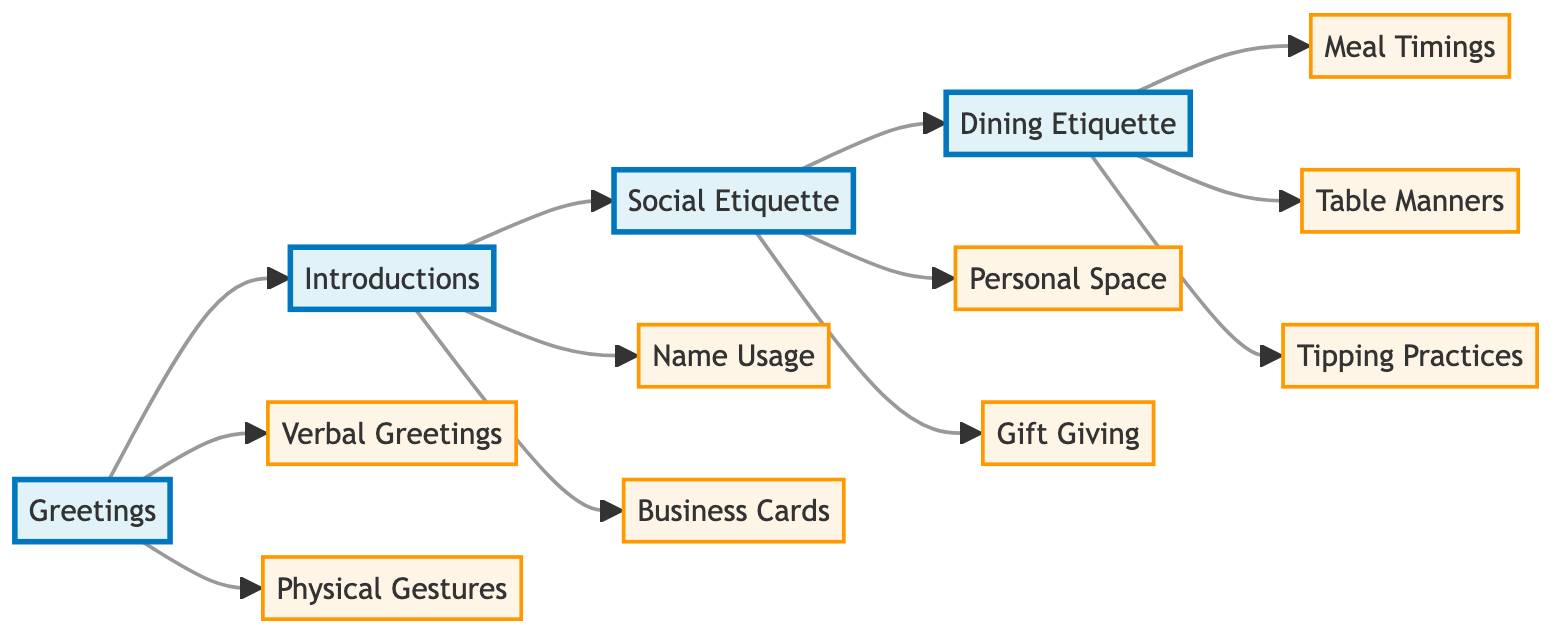What are the two main categories under Greetings? The flowchart shows two elements branching from the main stage "Greetings." These elements are "Verbal Greetings" and "Physical Gestures." Thus, these two are the primary categories discussed in this stage.
Answer: Verbal Greetings, Physical Gestures How many stages are there in the flowchart? The flowchart consists of four distinct stages: Greetings, Introductions, Social Etiquette, and Dining Etiquette. Therefore, counting these stages gives us the total number.
Answer: 4 What is the etiquette for Business Cards? The flowchart indicates that the etiquette involves presenting the cards with both hands in Japan. This is specifically mentioned under the "Business Cards" element in the Introductions stage.
Answer: Presenting with both hands in Japan Which stage discusses Meal Timings? By examining the flowchart, we can see that "Meal Timings" is listed under the stage "Dining Etiquette." This means it is part of the dining-related customs being conveyed.
Answer: Dining Etiquette What is the relationship between Personal Space and Gift Giving? In the flowchart, both "Personal Space" and "Gift Giving" are categorized under the "Social Etiquette" stage. They are closely connected as they both pertain to social norms and interactions, indicating that they share a common area of focus.
Answer: Social Etiquette What do you do before meals in Japan? The flowchart specifies that one should say "itadakimasu" before meals in Japan, which is detailed in the "Table Manners" section within the Dining Etiquette stage. This indicates a cultural practice that signifies appreciation before eating.
Answer: Itadakimasu How many elements are in the Dining Etiquette stage? By observing the flowchart, the Dining Etiquette stage includes three elements: "Meal Timings," "Table Manners," and "Tipping Practices." Counting these will give the total number of elements in this stage.
Answer: 3 What is emphasized by the Physical Gestures element? The flowchart highlights that Physical Gestures include actions like handshakes in the United States or bowing in Japan. Thus, this element emphasizes the importance of gestures in greetings across different cultures.
Answer: Handshakes, bow In which two cultures is the timing of meals notably different? The flowchart notes that Spain typically has late dinners around 9-10 PM, while other cultures may have different norms. Hence, two contrasting cultures regarding meal timing would be Spain and the United States.
Answer: Spain, United States What should you do when visiting a home in Russia? The flowchart suggests that it is customary to bring a small gift when visiting a home in Russia, as indicated under the "Gift Giving" element in the Social Etiquette stage.
Answer: Bring a small gift 